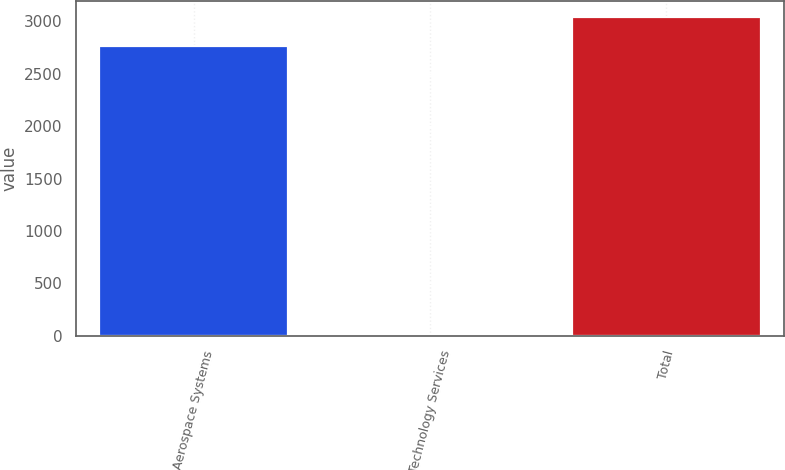<chart> <loc_0><loc_0><loc_500><loc_500><bar_chart><fcel>Aerospace Systems<fcel>Technology Services<fcel>Total<nl><fcel>2761<fcel>1<fcel>3037.1<nl></chart> 